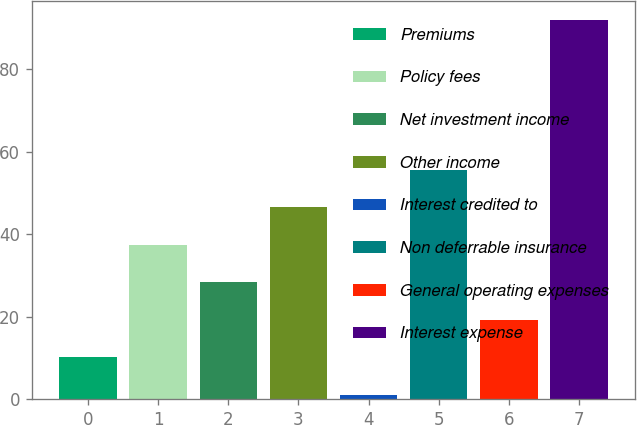Convert chart. <chart><loc_0><loc_0><loc_500><loc_500><bar_chart><fcel>Premiums<fcel>Policy fees<fcel>Net investment income<fcel>Other income<fcel>Interest credited to<fcel>Non deferrable insurance<fcel>General operating expenses<fcel>Interest expense<nl><fcel>10.1<fcel>37.4<fcel>28.3<fcel>46.5<fcel>1<fcel>55.6<fcel>19.2<fcel>92<nl></chart> 